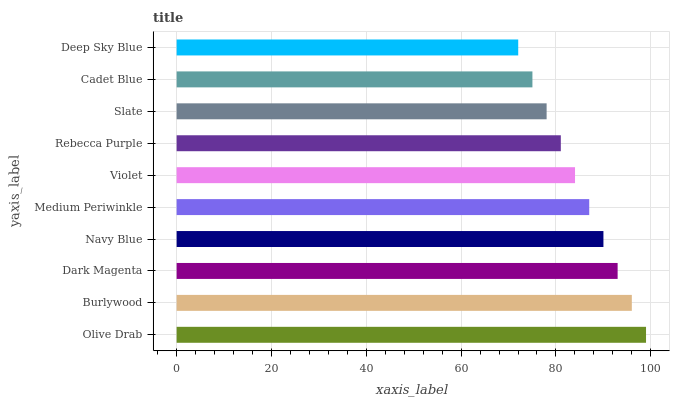Is Deep Sky Blue the minimum?
Answer yes or no. Yes. Is Olive Drab the maximum?
Answer yes or no. Yes. Is Burlywood the minimum?
Answer yes or no. No. Is Burlywood the maximum?
Answer yes or no. No. Is Olive Drab greater than Burlywood?
Answer yes or no. Yes. Is Burlywood less than Olive Drab?
Answer yes or no. Yes. Is Burlywood greater than Olive Drab?
Answer yes or no. No. Is Olive Drab less than Burlywood?
Answer yes or no. No. Is Medium Periwinkle the high median?
Answer yes or no. Yes. Is Violet the low median?
Answer yes or no. Yes. Is Dark Magenta the high median?
Answer yes or no. No. Is Burlywood the low median?
Answer yes or no. No. 